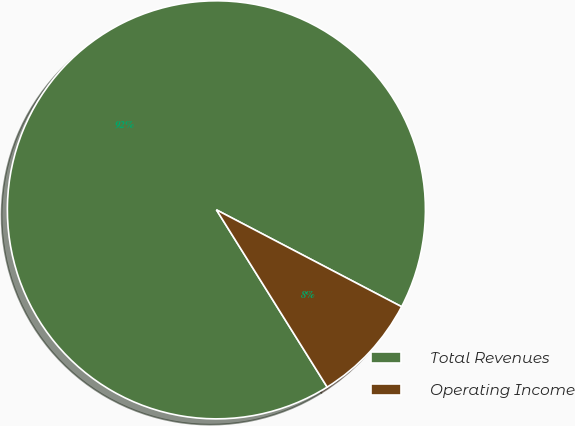Convert chart. <chart><loc_0><loc_0><loc_500><loc_500><pie_chart><fcel>Total Revenues<fcel>Operating Income<nl><fcel>91.56%<fcel>8.44%<nl></chart> 